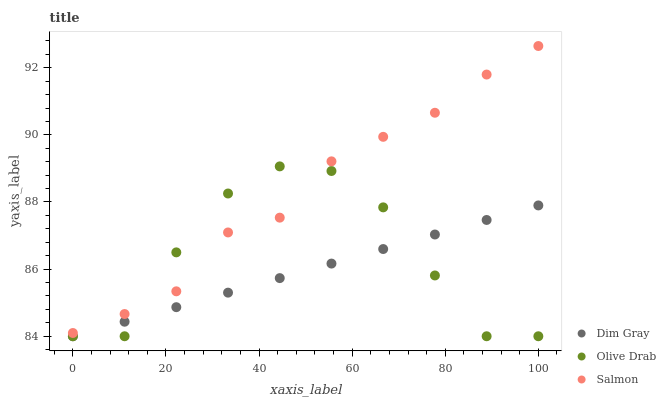Does Dim Gray have the minimum area under the curve?
Answer yes or no. Yes. Does Salmon have the maximum area under the curve?
Answer yes or no. Yes. Does Olive Drab have the minimum area under the curve?
Answer yes or no. No. Does Olive Drab have the maximum area under the curve?
Answer yes or no. No. Is Dim Gray the smoothest?
Answer yes or no. Yes. Is Olive Drab the roughest?
Answer yes or no. Yes. Is Salmon the smoothest?
Answer yes or no. No. Is Salmon the roughest?
Answer yes or no. No. Does Dim Gray have the lowest value?
Answer yes or no. Yes. Does Salmon have the lowest value?
Answer yes or no. No. Does Salmon have the highest value?
Answer yes or no. Yes. Does Olive Drab have the highest value?
Answer yes or no. No. Is Dim Gray less than Salmon?
Answer yes or no. Yes. Is Salmon greater than Dim Gray?
Answer yes or no. Yes. Does Olive Drab intersect Salmon?
Answer yes or no. Yes. Is Olive Drab less than Salmon?
Answer yes or no. No. Is Olive Drab greater than Salmon?
Answer yes or no. No. Does Dim Gray intersect Salmon?
Answer yes or no. No. 